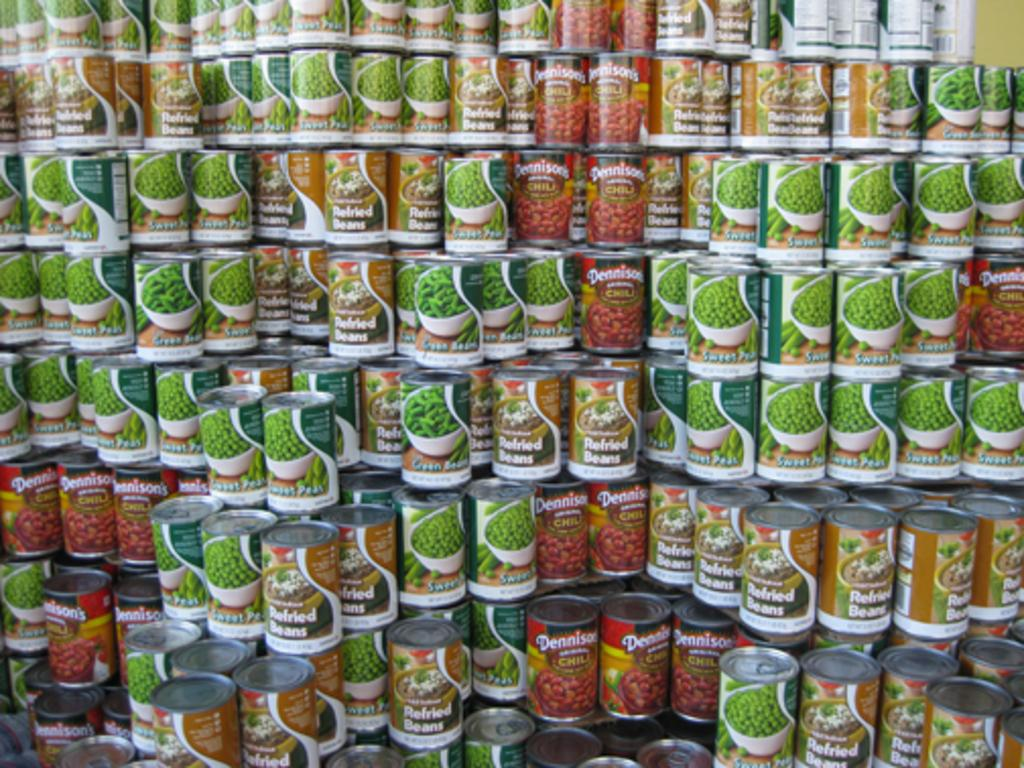What type of product bottles are present in the image? The picture contains snap pea product bottles. Can you describe the contents of the bottles? The contents of the bottles are not visible in the image, but they are snap pea products. Where can you buy a book about faces in the image? There is no book about faces present in the image, nor is there a shop or any reference to purchasing items. 